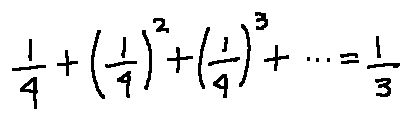Convert formula to latex. <formula><loc_0><loc_0><loc_500><loc_500>\frac { 1 } { 4 } + ( \frac { 1 } { 4 } ) ^ { 2 } + ( \frac { 1 } { 4 } ) ^ { 3 } + \cdots = \frac { 1 } { 3 }</formula> 